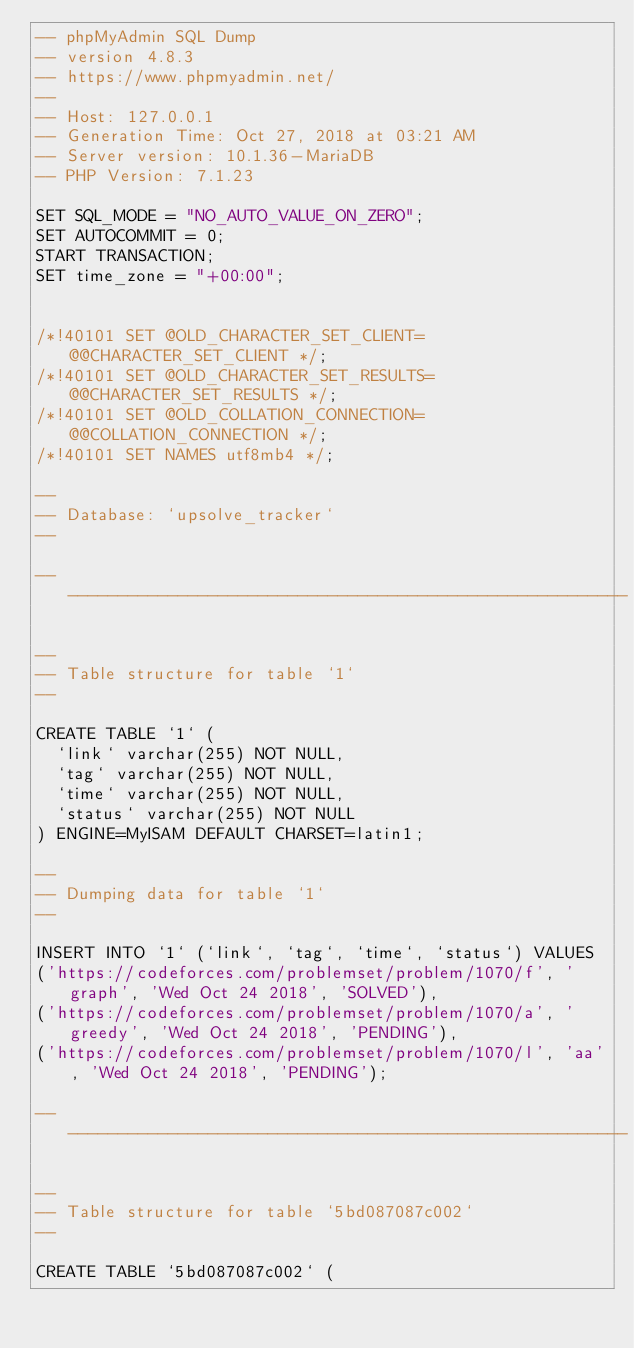<code> <loc_0><loc_0><loc_500><loc_500><_SQL_>-- phpMyAdmin SQL Dump
-- version 4.8.3
-- https://www.phpmyadmin.net/
--
-- Host: 127.0.0.1
-- Generation Time: Oct 27, 2018 at 03:21 AM
-- Server version: 10.1.36-MariaDB
-- PHP Version: 7.1.23

SET SQL_MODE = "NO_AUTO_VALUE_ON_ZERO";
SET AUTOCOMMIT = 0;
START TRANSACTION;
SET time_zone = "+00:00";


/*!40101 SET @OLD_CHARACTER_SET_CLIENT=@@CHARACTER_SET_CLIENT */;
/*!40101 SET @OLD_CHARACTER_SET_RESULTS=@@CHARACTER_SET_RESULTS */;
/*!40101 SET @OLD_COLLATION_CONNECTION=@@COLLATION_CONNECTION */;
/*!40101 SET NAMES utf8mb4 */;

--
-- Database: `upsolve_tracker`
--

-- --------------------------------------------------------

--
-- Table structure for table `1`
--

CREATE TABLE `1` (
  `link` varchar(255) NOT NULL,
  `tag` varchar(255) NOT NULL,
  `time` varchar(255) NOT NULL,
  `status` varchar(255) NOT NULL
) ENGINE=MyISAM DEFAULT CHARSET=latin1;

--
-- Dumping data for table `1`
--

INSERT INTO `1` (`link`, `tag`, `time`, `status`) VALUES
('https://codeforces.com/problemset/problem/1070/f', 'graph', 'Wed Oct 24 2018', 'SOLVED'),
('https://codeforces.com/problemset/problem/1070/a', 'greedy', 'Wed Oct 24 2018', 'PENDING'),
('https://codeforces.com/problemset/problem/1070/l', 'aa', 'Wed Oct 24 2018', 'PENDING');

-- --------------------------------------------------------

--
-- Table structure for table `5bd087087c002`
--

CREATE TABLE `5bd087087c002` (</code> 